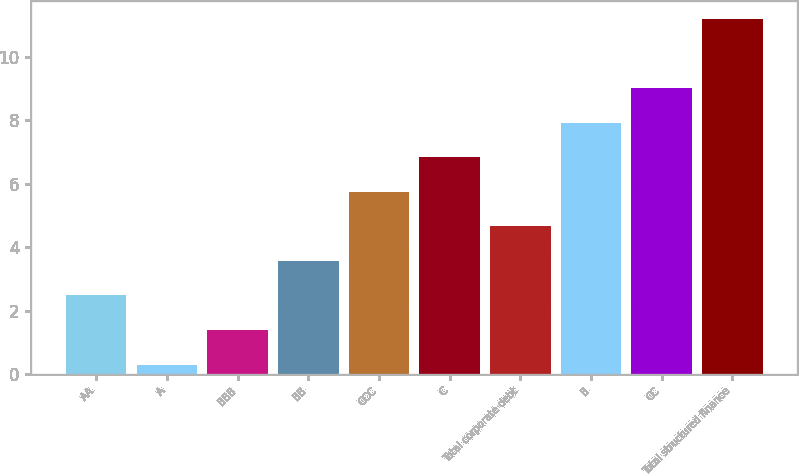Convert chart to OTSL. <chart><loc_0><loc_0><loc_500><loc_500><bar_chart><fcel>AA<fcel>A<fcel>BBB<fcel>BB<fcel>CCC<fcel>C<fcel>Total corporate debt<fcel>B<fcel>CC<fcel>Total structured finance<nl><fcel>2.48<fcel>0.3<fcel>1.39<fcel>3.57<fcel>5.75<fcel>6.84<fcel>4.66<fcel>7.93<fcel>9.02<fcel>11.2<nl></chart> 